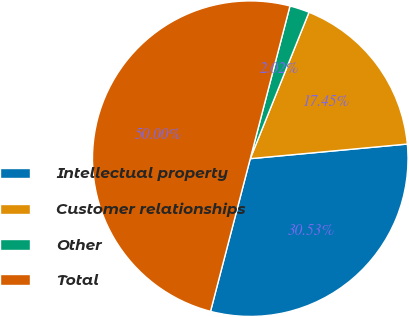Convert chart. <chart><loc_0><loc_0><loc_500><loc_500><pie_chart><fcel>Intellectual property<fcel>Customer relationships<fcel>Other<fcel>Total<nl><fcel>30.53%<fcel>17.45%<fcel>2.02%<fcel>50.0%<nl></chart> 